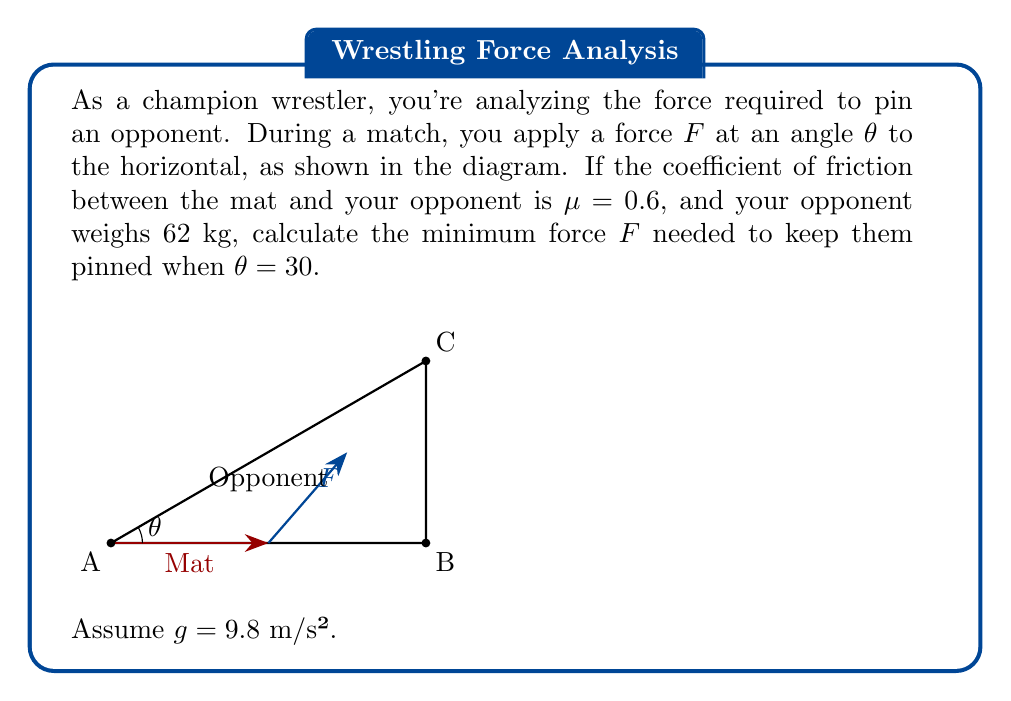Could you help me with this problem? Let's solve this step-by-step:

1) First, we need to determine the normal force $N$ and the weight $W$ of the opponent:
   $W = mg = 62 \cdot 9.8 = 607.6$ N

2) For the opponent to remain pinned, the friction force must be greater than or equal to the component of $F$ parallel to the mat:
   $\mu N \geq F \cos \theta$

3) The normal force $N$ is the sum of the weight and the vertical component of $F$:
   $N = W + F \sin \theta$

4) Substituting this into the friction inequality:
   $\mu (W + F \sin \theta) \geq F \cos \theta$

5) Expanding:
   $\mu W + \mu F \sin \theta \geq F \cos \theta$

6) Rearranging to solve for $F$:
   $\mu W \geq F \cos \theta - \mu F \sin \theta$
   $\mu W \geq F (\cos \theta - \mu \sin \theta)$

7) Therefore:
   $F \geq \frac{\mu W}{\cos \theta - \mu \sin \theta}$

8) Substituting the known values:
   $F \geq \frac{0.6 \cdot 607.6}{\cos 30° - 0.6 \sin 30°}$

9) Calculating:
   $F \geq \frac{364.56}{0.866 - 0.6 \cdot 0.5} = \frac{364.56}{0.566} = 643.75$ N

Therefore, the minimum force required is approximately 643.75 N.
Answer: $F \geq 643.75$ N 